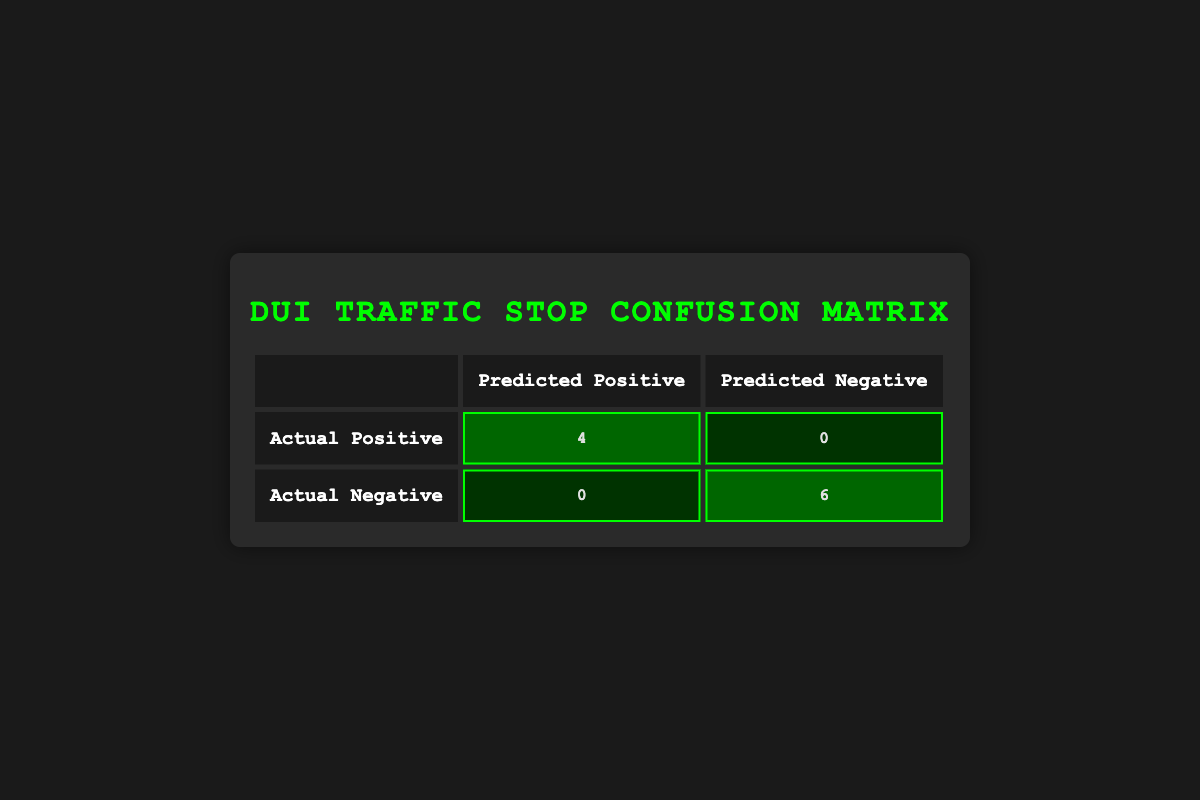What is the total number of actual DUI incidents? To find the total number of actual DUI incidents, we look at the "Actual Positive" row in the table, which shows there were 4 actual positives. Therefore, the total number of actual DUI incidents is 4.
Answer: 4 How many traffic stops resulted in predicted negative outcomes? In the "Actual Negative" row, the number of predicted negative outcomes is indicated to be 6. This shows the stops that accurately predicted no DUI.
Answer: 6 What is the total number of false negative incidents? The table indicates that there are 0 false negative incidents in the "Actual Positive" row, where the count for predicted negative is shown. Therefore, the total number of false negatives is 0.
Answer: 0 Is the number of actual DUIs equal to the number of false positives? The number of actual DUIs is 4, and the table indicates that there are 0 false positives. Since 4 does not equal 0, the answer is no.
Answer: No What is the total number of predicted positives? The predicted positive outcomes are found in the "Predicted Positive" column of the table, which has a total of 4 true positives and 0 false positives, resulting in a total of 4 predicted positives.
Answer: 4 What percentage of the predicted positives were true positives? There are 4 true positives and 0 false positives, making a total of 4 predicted positives. To find the percentage, use the formula (true positives / total predicted positives) * 100, which is (4 / 4) * 100 = 100%.
Answer: 100% If a traffic stop results in an arrest, what is the likelihood that it is an actual DUI incident? The number of traffic stops resulting in arrests is represented by the true positives (4), and based on the confusion matrix, the likelihood can be calculated as (true positives / (true positives + false positives)) = 4 / (4 + 0), which equals 1 or 100%.
Answer: 100% How many total traffic stops are represented in the table? The total traffic stops can be calculated by adding the values from both the "Actual Positive" and "Actual Negative" rows. Thus, 4 (actual positives) + 6 (actual negatives) gives us a total of 10 traffic stops.
Answer: 10 What is the ratio of false positives to actual negatives? The confusion matrix shows there are 0 false positives and 6 actual negatives. The ratio of false positives to actual negatives is 0:6; when simplified, this is 0.
Answer: 0 